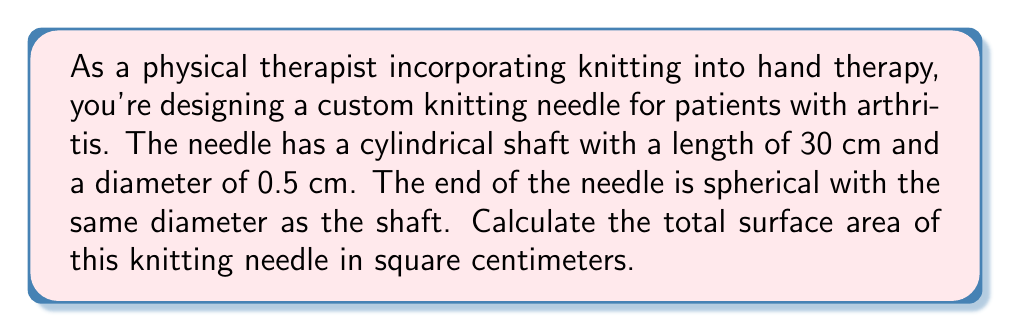What is the answer to this math problem? To solve this problem, we need to calculate the surface area of three parts:
1. The cylindrical shaft
2. The spherical end
3. The circular base where the shaft meets the spherical end

1. Surface area of the cylindrical shaft:
   The formula for the lateral surface area of a cylinder is $A = 2\pi rh$
   where $r$ is the radius and $h$ is the height (length) of the cylinder.
   $$A_{cylinder} = 2\pi \cdot (0.25\text{ cm}) \cdot (30\text{ cm}) = 15\pi\text{ cm}^2$$

2. Surface area of the spherical end:
   The formula for the surface area of a sphere is $A = 4\pi r^2$
   However, we only need half of this since the sphere is attached to the cylinder.
   $$A_{sphere} = \frac{1}{2} \cdot 4\pi \cdot (0.25\text{ cm})^2 = \frac{1}{4}\pi\text{ cm}^2$$

3. Area of the circular base:
   The formula for the area of a circle is $A = \pi r^2$
   $$A_{base} = \pi \cdot (0.25\text{ cm})^2 = \frac{1}{16}\pi\text{ cm}^2$$

Now, we sum up all these areas:
$$A_{total} = A_{cylinder} + A_{sphere} - A_{base}$$
$$A_{total} = 15\pi\text{ cm}^2 + \frac{1}{4}\pi\text{ cm}^2 - \frac{1}{16}\pi\text{ cm}^2$$
$$A_{total} = \left(15 + \frac{1}{4} - \frac{1}{16}\right)\pi\text{ cm}^2$$
$$A_{total} = \frac{243}{16}\pi\text{ cm}^2 \approx 47.75\text{ cm}^2$$
Answer: $\frac{243}{16}\pi\text{ cm}^2$ or approximately $47.75\text{ cm}^2$ 